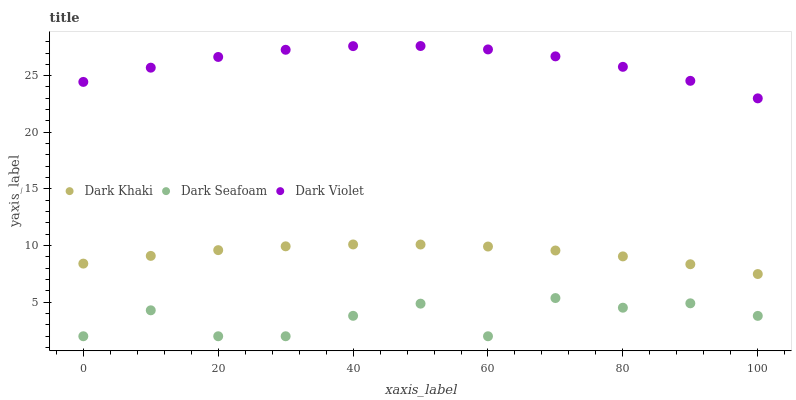Does Dark Seafoam have the minimum area under the curve?
Answer yes or no. Yes. Does Dark Violet have the maximum area under the curve?
Answer yes or no. Yes. Does Dark Violet have the minimum area under the curve?
Answer yes or no. No. Does Dark Seafoam have the maximum area under the curve?
Answer yes or no. No. Is Dark Khaki the smoothest?
Answer yes or no. Yes. Is Dark Seafoam the roughest?
Answer yes or no. Yes. Is Dark Violet the smoothest?
Answer yes or no. No. Is Dark Violet the roughest?
Answer yes or no. No. Does Dark Seafoam have the lowest value?
Answer yes or no. Yes. Does Dark Violet have the lowest value?
Answer yes or no. No. Does Dark Violet have the highest value?
Answer yes or no. Yes. Does Dark Seafoam have the highest value?
Answer yes or no. No. Is Dark Khaki less than Dark Violet?
Answer yes or no. Yes. Is Dark Khaki greater than Dark Seafoam?
Answer yes or no. Yes. Does Dark Khaki intersect Dark Violet?
Answer yes or no. No. 